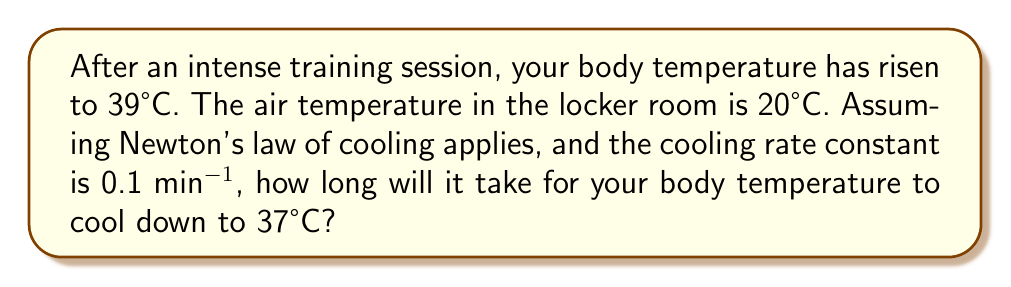Provide a solution to this math problem. Let's approach this step-by-step using Newton's law of cooling:

1) Newton's law of cooling states that the rate of change of the temperature of an object is proportional to the difference between its own temperature and the ambient temperature.

2) Let $T(t)$ be the temperature of the body at time $t$, $T_a$ be the ambient temperature, and $k$ be the cooling rate constant. The differential equation is:

   $$\frac{dT}{dt} = -k(T - T_a)$$

3) We're given:
   - Initial temperature $T_0 = 39°C$
   - Ambient temperature $T_a = 20°C$
   - Cooling rate constant $k = 0.1$ min^(-1)
   - Final temperature $T = 37°C$

4) The solution to this differential equation is:

   $$T(t) = T_a + (T_0 - T_a)e^{-kt}$$

5) Substituting our values:

   $$37 = 20 + (39 - 20)e^{-0.1t}$$

6) Simplifying:

   $$17 = 19e^{-0.1t}$$

7) Dividing both sides by 19:

   $$\frac{17}{19} = e^{-0.1t}$$

8) Taking the natural log of both sides:

   $$\ln(\frac{17}{19}) = -0.1t$$

9) Solving for $t$:

   $$t = -\frac{\ln(\frac{17}{19})}{0.1} \approx 11.12$$

Therefore, it will take approximately 11.12 minutes for your body temperature to cool down to 37°C.
Answer: 11.12 minutes 